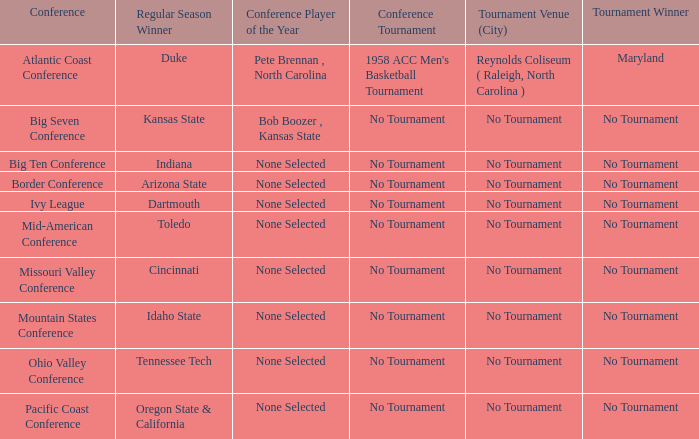Who emerged victorious in the competition when idaho state claimed the regular season? No Tournament. 